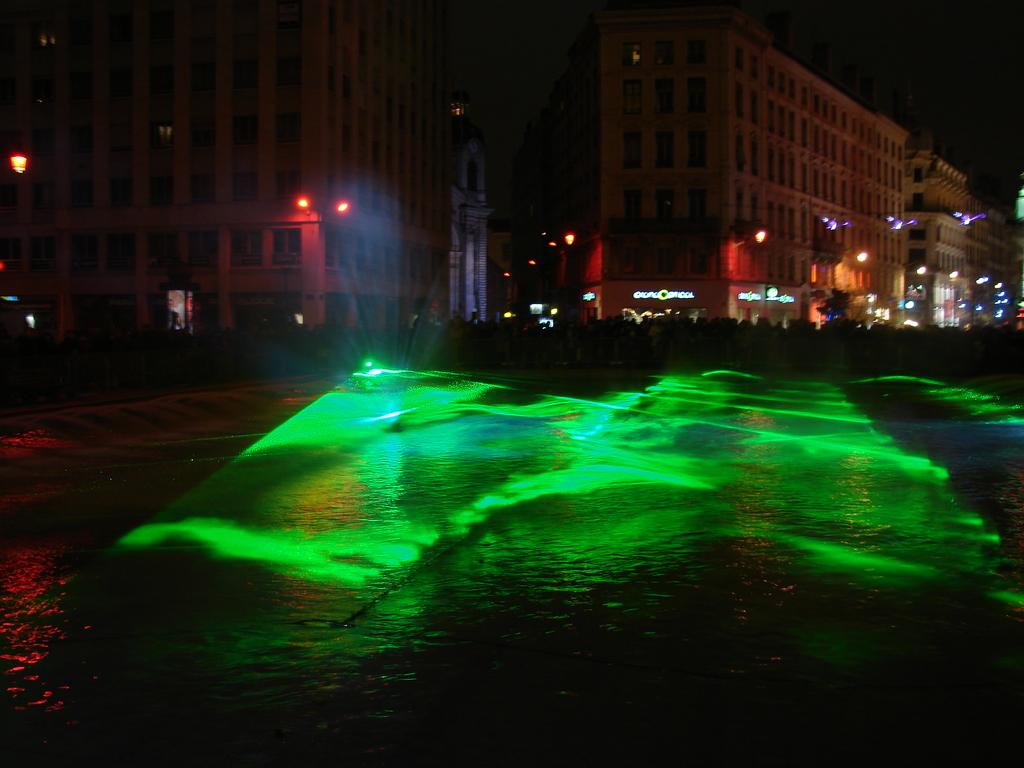What type of structures can be seen in the image? There are buildings in the image. What else is visible in the image besides the buildings? There are lights and boards visible in the image. What can be seen at the bottom of the image? There is water visible at the bottom of the image. What type of hands can be seen playing on the playground in the image? There is no playground or hands present in the image. 